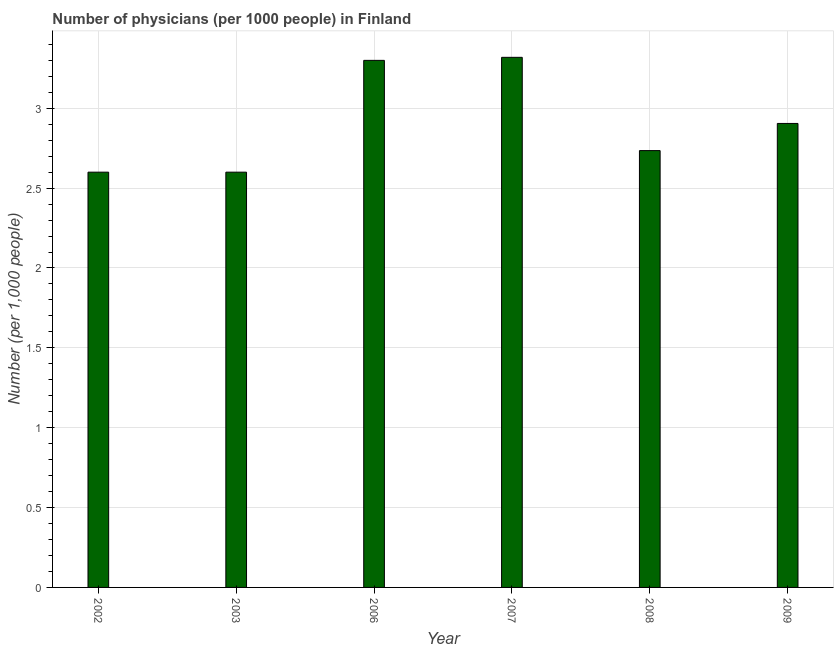Does the graph contain grids?
Ensure brevity in your answer.  Yes. What is the title of the graph?
Your answer should be very brief. Number of physicians (per 1000 people) in Finland. What is the label or title of the X-axis?
Give a very brief answer. Year. What is the label or title of the Y-axis?
Provide a short and direct response. Number (per 1,0 people). What is the number of physicians in 2007?
Give a very brief answer. 3.32. Across all years, what is the maximum number of physicians?
Your answer should be very brief. 3.32. In which year was the number of physicians maximum?
Your answer should be compact. 2007. What is the sum of the number of physicians?
Make the answer very short. 17.46. What is the difference between the number of physicians in 2003 and 2006?
Your answer should be compact. -0.7. What is the average number of physicians per year?
Provide a succinct answer. 2.91. What is the median number of physicians?
Your answer should be very brief. 2.82. In how many years, is the number of physicians greater than 0.1 ?
Your answer should be compact. 6. What is the ratio of the number of physicians in 2006 to that in 2009?
Offer a terse response. 1.14. Is the number of physicians in 2002 less than that in 2007?
Ensure brevity in your answer.  Yes. What is the difference between the highest and the second highest number of physicians?
Your answer should be compact. 0.02. What is the difference between the highest and the lowest number of physicians?
Keep it short and to the point. 0.72. How many bars are there?
Keep it short and to the point. 6. What is the Number (per 1,000 people) of 2002?
Your answer should be very brief. 2.6. What is the Number (per 1,000 people) of 2003?
Ensure brevity in your answer.  2.6. What is the Number (per 1,000 people) in 2007?
Offer a very short reply. 3.32. What is the Number (per 1,000 people) in 2008?
Offer a very short reply. 2.73. What is the Number (per 1,000 people) of 2009?
Your response must be concise. 2.9. What is the difference between the Number (per 1,000 people) in 2002 and 2007?
Keep it short and to the point. -0.72. What is the difference between the Number (per 1,000 people) in 2002 and 2008?
Offer a terse response. -0.14. What is the difference between the Number (per 1,000 people) in 2002 and 2009?
Give a very brief answer. -0.3. What is the difference between the Number (per 1,000 people) in 2003 and 2007?
Provide a short and direct response. -0.72. What is the difference between the Number (per 1,000 people) in 2003 and 2008?
Your response must be concise. -0.14. What is the difference between the Number (per 1,000 people) in 2003 and 2009?
Keep it short and to the point. -0.3. What is the difference between the Number (per 1,000 people) in 2006 and 2007?
Offer a very short reply. -0.02. What is the difference between the Number (per 1,000 people) in 2006 and 2008?
Your answer should be compact. 0.56. What is the difference between the Number (per 1,000 people) in 2006 and 2009?
Give a very brief answer. 0.4. What is the difference between the Number (per 1,000 people) in 2007 and 2008?
Ensure brevity in your answer.  0.58. What is the difference between the Number (per 1,000 people) in 2007 and 2009?
Your answer should be very brief. 0.41. What is the difference between the Number (per 1,000 people) in 2008 and 2009?
Offer a very short reply. -0.17. What is the ratio of the Number (per 1,000 people) in 2002 to that in 2003?
Keep it short and to the point. 1. What is the ratio of the Number (per 1,000 people) in 2002 to that in 2006?
Offer a very short reply. 0.79. What is the ratio of the Number (per 1,000 people) in 2002 to that in 2007?
Provide a succinct answer. 0.78. What is the ratio of the Number (per 1,000 people) in 2002 to that in 2008?
Your answer should be compact. 0.95. What is the ratio of the Number (per 1,000 people) in 2002 to that in 2009?
Your answer should be compact. 0.9. What is the ratio of the Number (per 1,000 people) in 2003 to that in 2006?
Give a very brief answer. 0.79. What is the ratio of the Number (per 1,000 people) in 2003 to that in 2007?
Your answer should be compact. 0.78. What is the ratio of the Number (per 1,000 people) in 2003 to that in 2008?
Provide a succinct answer. 0.95. What is the ratio of the Number (per 1,000 people) in 2003 to that in 2009?
Your response must be concise. 0.9. What is the ratio of the Number (per 1,000 people) in 2006 to that in 2007?
Give a very brief answer. 0.99. What is the ratio of the Number (per 1,000 people) in 2006 to that in 2008?
Your answer should be very brief. 1.21. What is the ratio of the Number (per 1,000 people) in 2006 to that in 2009?
Give a very brief answer. 1.14. What is the ratio of the Number (per 1,000 people) in 2007 to that in 2008?
Offer a very short reply. 1.21. What is the ratio of the Number (per 1,000 people) in 2007 to that in 2009?
Make the answer very short. 1.14. What is the ratio of the Number (per 1,000 people) in 2008 to that in 2009?
Make the answer very short. 0.94. 